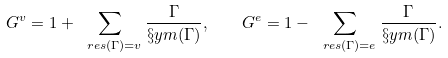Convert formula to latex. <formula><loc_0><loc_0><loc_500><loc_500>G ^ { v } = 1 + \sum _ { \ r e s ( \Gamma ) = v } \frac { \Gamma } { \S y m ( \Gamma ) } , \quad G ^ { e } = 1 - \sum _ { \ r e s ( \Gamma ) = e } \frac { \Gamma } { \S y m ( \Gamma ) } .</formula> 